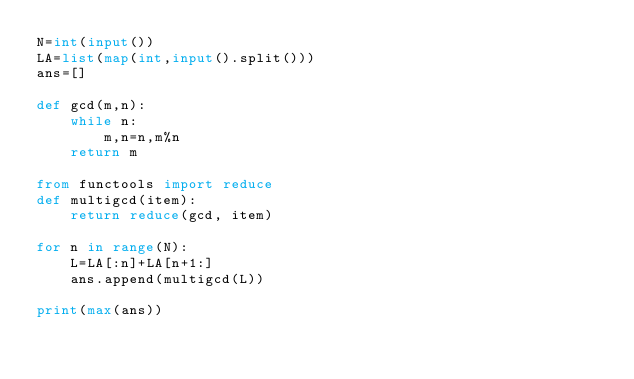Convert code to text. <code><loc_0><loc_0><loc_500><loc_500><_Python_>N=int(input())
LA=list(map(int,input().split()))
ans=[]

def gcd(m,n):
    while n:
        m,n=n,m%n
    return m

from functools import reduce
def multigcd(item):
    return reduce(gcd, item)

for n in range(N):
    L=LA[:n]+LA[n+1:]
    ans.append(multigcd(L))

print(max(ans))</code> 